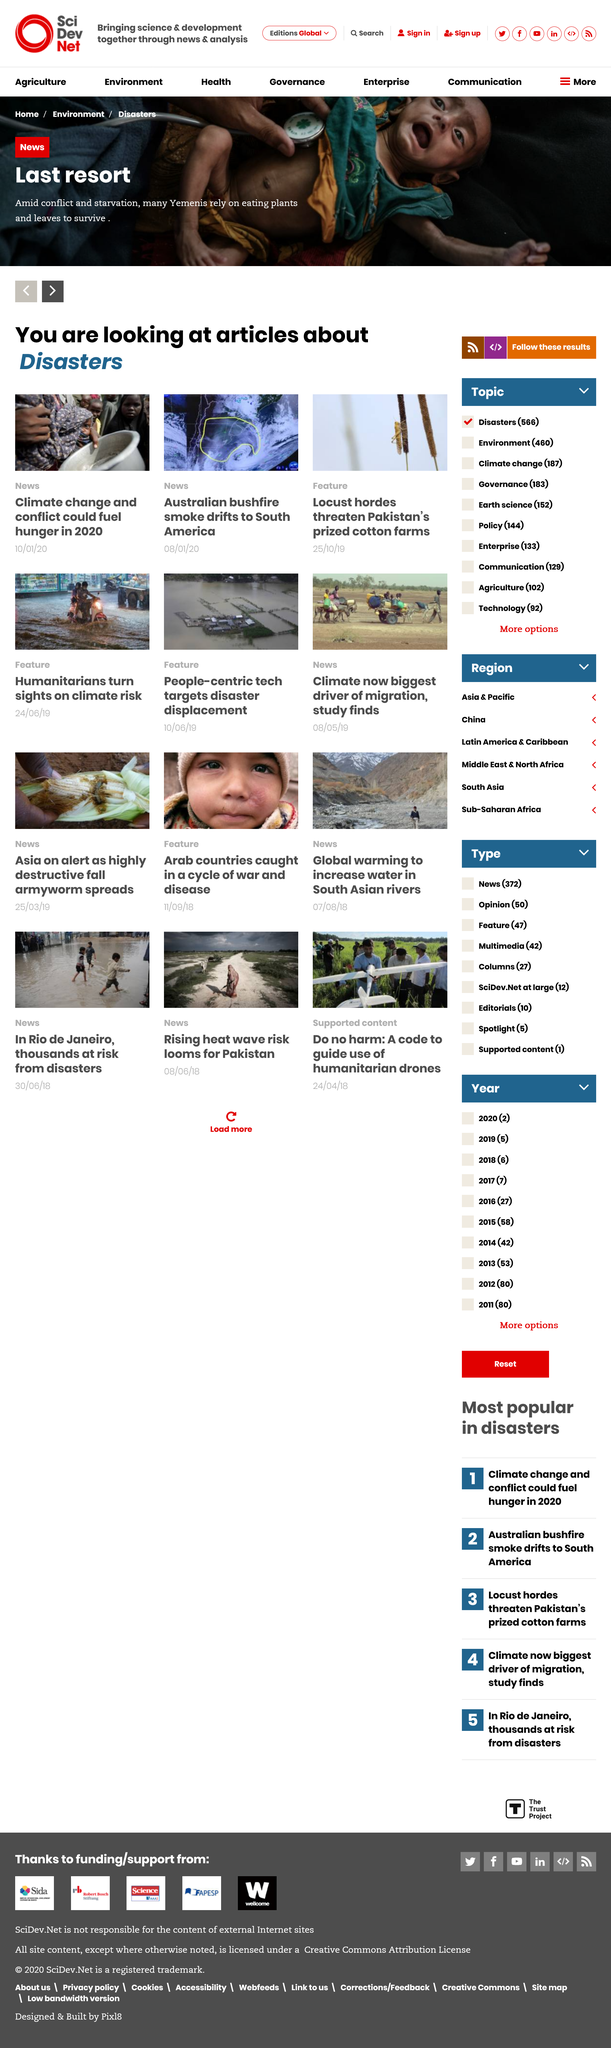Give some essential details in this illustration. Climate change and conflict could fuel hunger in 2020. The smoke from the devastating Australian bushfires is drifting towards South America, causing concern and harm to the environment and the people in its path. The article on locust hordes falls under the Feature category. 